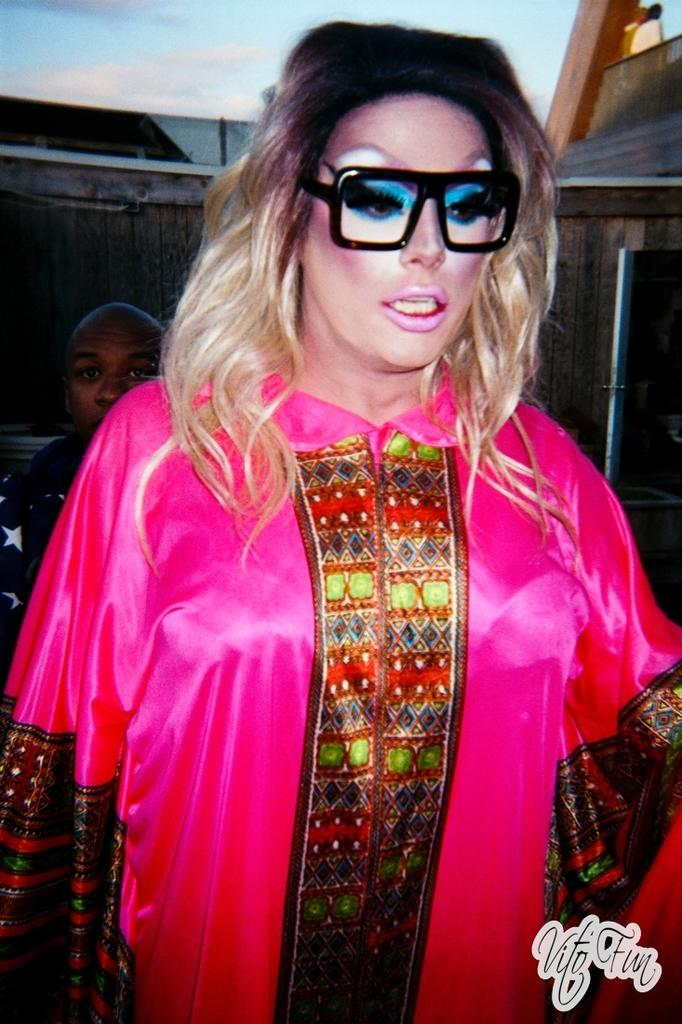What is the person in the foreground of the image wearing? The person in the foreground of the image is wearing spectacles. Can you describe the person behind the person wearing spectacles? There is another person behind the person wearing spectacles, but no specific details about this person are provided. What type of bubble can be seen floating near the person wearing spectacles in the image? There is no bubble present in the image. 